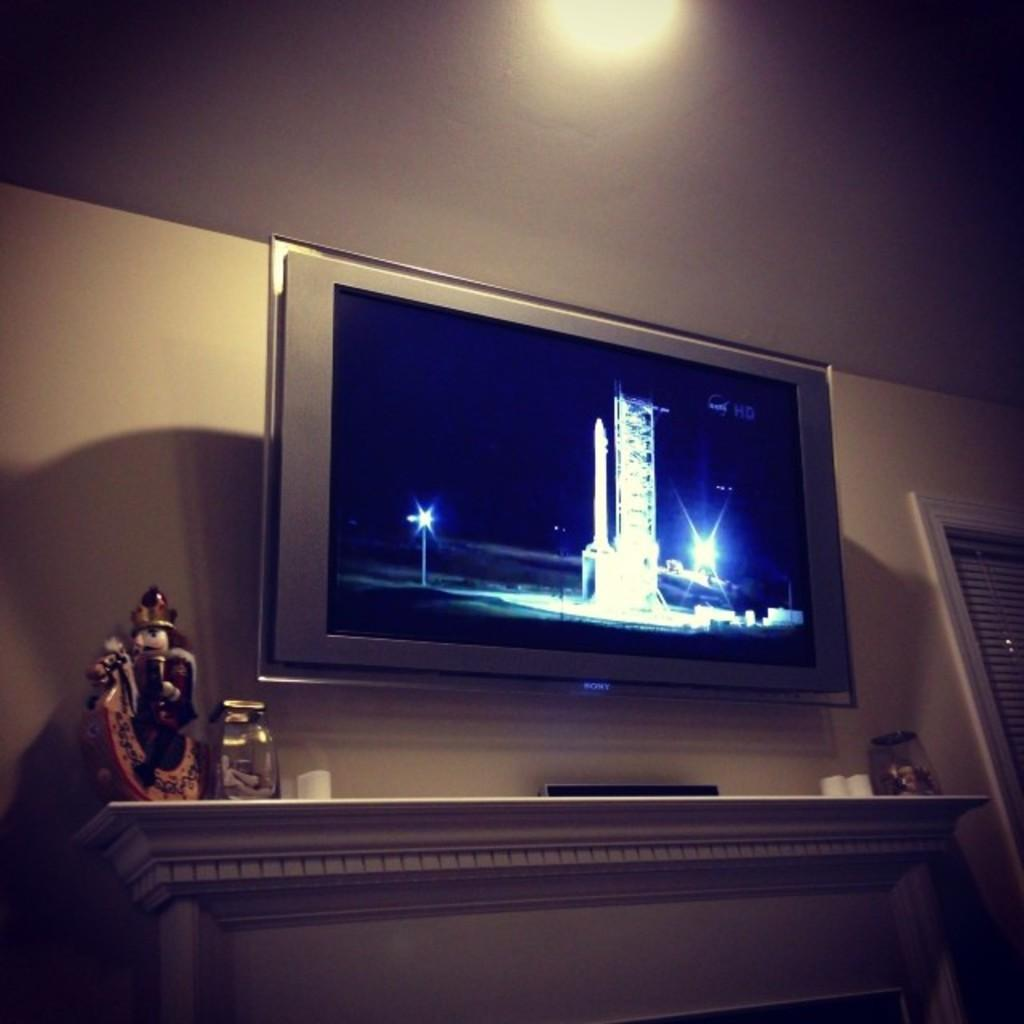Where is the television located in the image? The television is fixed to the wall in the image. What is on the desk in the image? There is an idol and a jar on the desk in the image. What can be seen on the right side of the image? There is a window on the right side of the image. What language is the steam speaking in the image? There is no steam present in the image, so it cannot be speaking any language. 